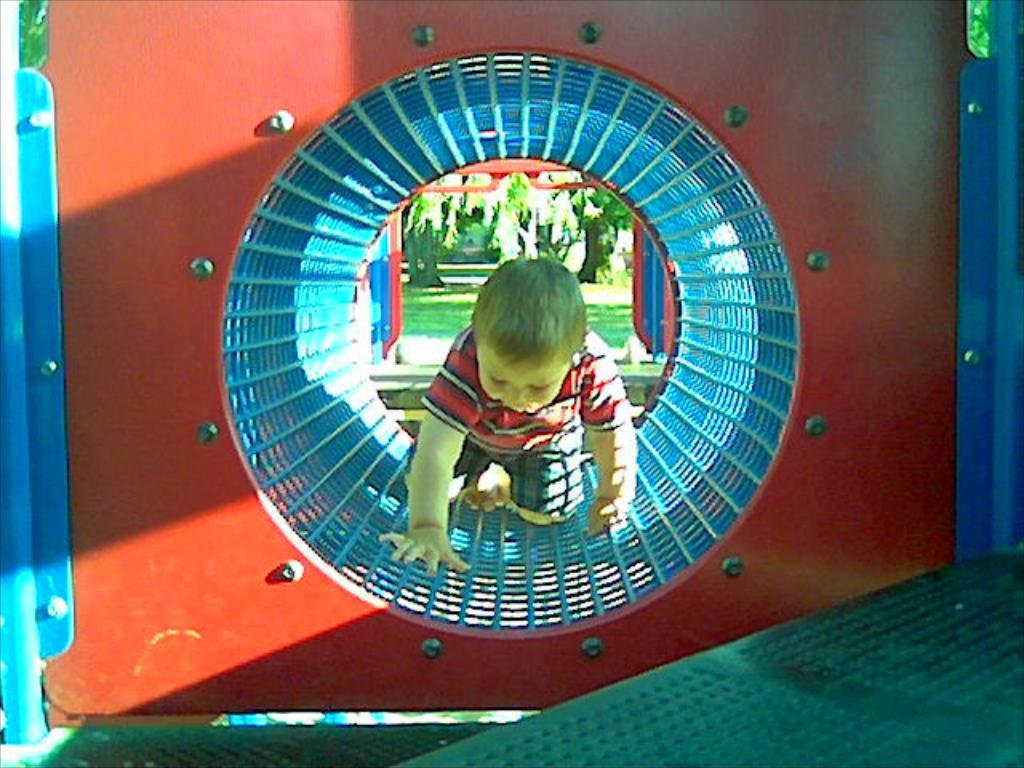What color is the prominent object in the image? There is a red object in the image. Who or what is located in the center of the red object? A boy is in the center of the red object. What can be seen in the background of the image? There are trees in the background of the image. Can you see any smoke coming from the hat in the image? There is no hat present in the image, and therefore no smoke can be seen coming from it. 